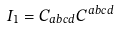<formula> <loc_0><loc_0><loc_500><loc_500>I _ { 1 } = C _ { a b c d } C ^ { a b c d }</formula> 